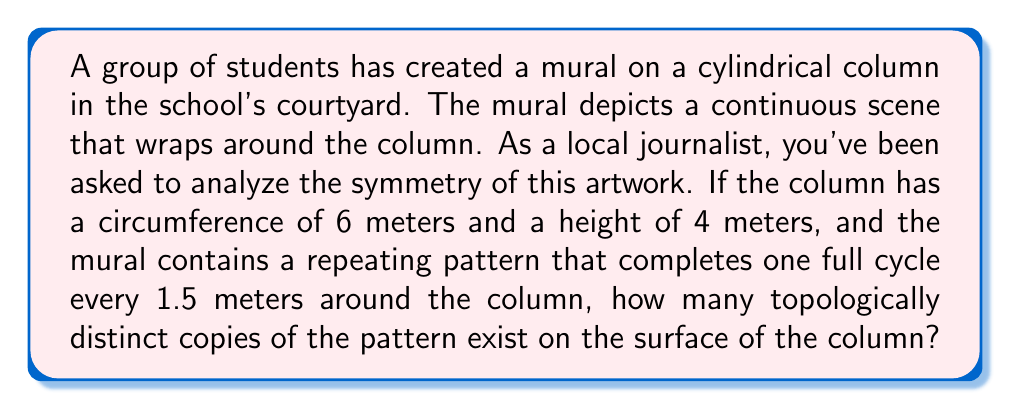What is the answer to this math problem? To solve this problem, we need to think about the topological properties of the cylindrical surface and how the repeating pattern maps onto it. Let's approach this step-by-step:

1) First, we need to understand that a cylinder can be represented as a flat rectangle where the left and right edges are identified (glued together). This is because topologically, a cylinder is equivalent to a rectangle with its vertical edges identified.

2) The circumference of the column is 6 meters, and the pattern repeats every 1.5 meters. To find how many times the pattern repeats around the circumference, we calculate:

   $$ \text{Number of repetitions} = \frac{\text{Circumference}}{\text{Pattern length}} = \frac{6 \text{ m}}{1.5 \text{ m}} = 4 $$

3) This means that as we go around the column once, we see the pattern repeated 4 times.

4) Now, we need to consider if there are any additional symmetries in the vertical direction. The height of the column is 4 meters, but we don't have any information about vertical repetition. Therefore, we assume the pattern only repeats horizontally.

5) In topological terms, we can think of this as a mapping from the rectangle (before it's rolled into a cylinder) to the pattern space. Each topologically distinct copy of the pattern corresponds to a fundamental domain of this mapping.

6) Since we have 4 repetitions horizontally and no specified repetition vertically, there are 4 topologically distinct copies of the pattern on the surface of the column.

This analysis reveals how the students have used the cylindrical surface to create a repeating pattern with rotational symmetry, effectively using the topology of the column to enhance their artistic expression.
Answer: 4 topologically distinct copies 